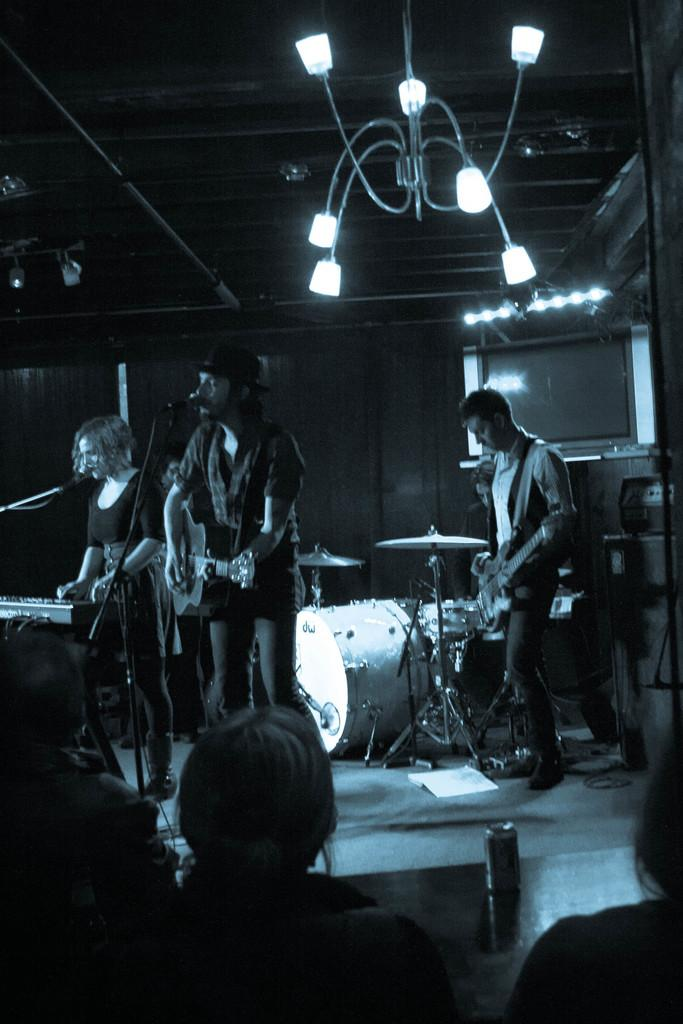How many musicians are playing in the image? There are four people playing musical instruments in the image. What can be seen in front of the musicians? There are people standing in front of the musicians. What is hanging above the people in the image? There is a lamp above the people in the image. What is attached to the wall in the image? There is a screen attached to a wall in the image. What type of writing can be seen on the cup held by one of the musicians? There is no cup visible in the image, and therefore no writing can be observed on it. 